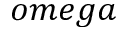<formula> <loc_0><loc_0><loc_500><loc_500>o m e g a</formula> 